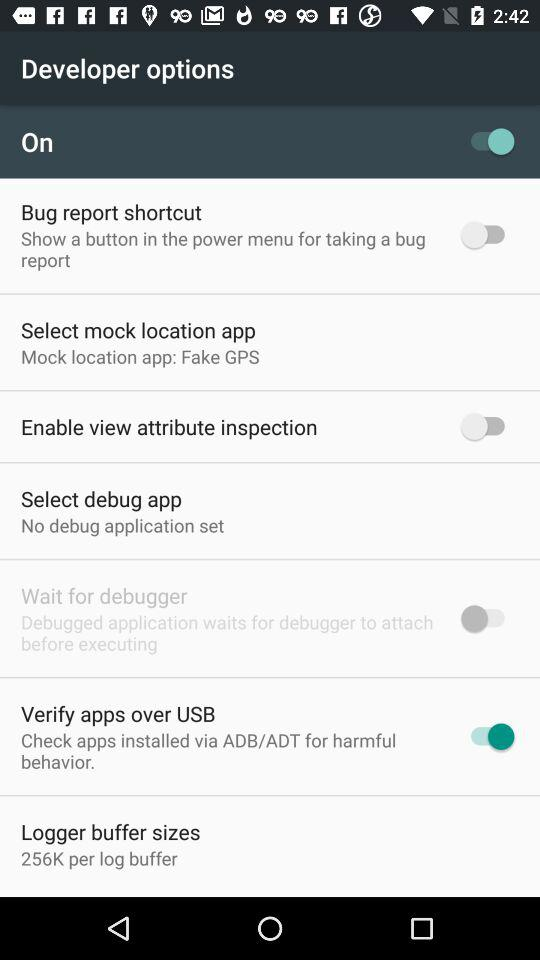Is "Select debug app" checked or unchecked?
When the provided information is insufficient, respond with <no answer>. <no answer> 